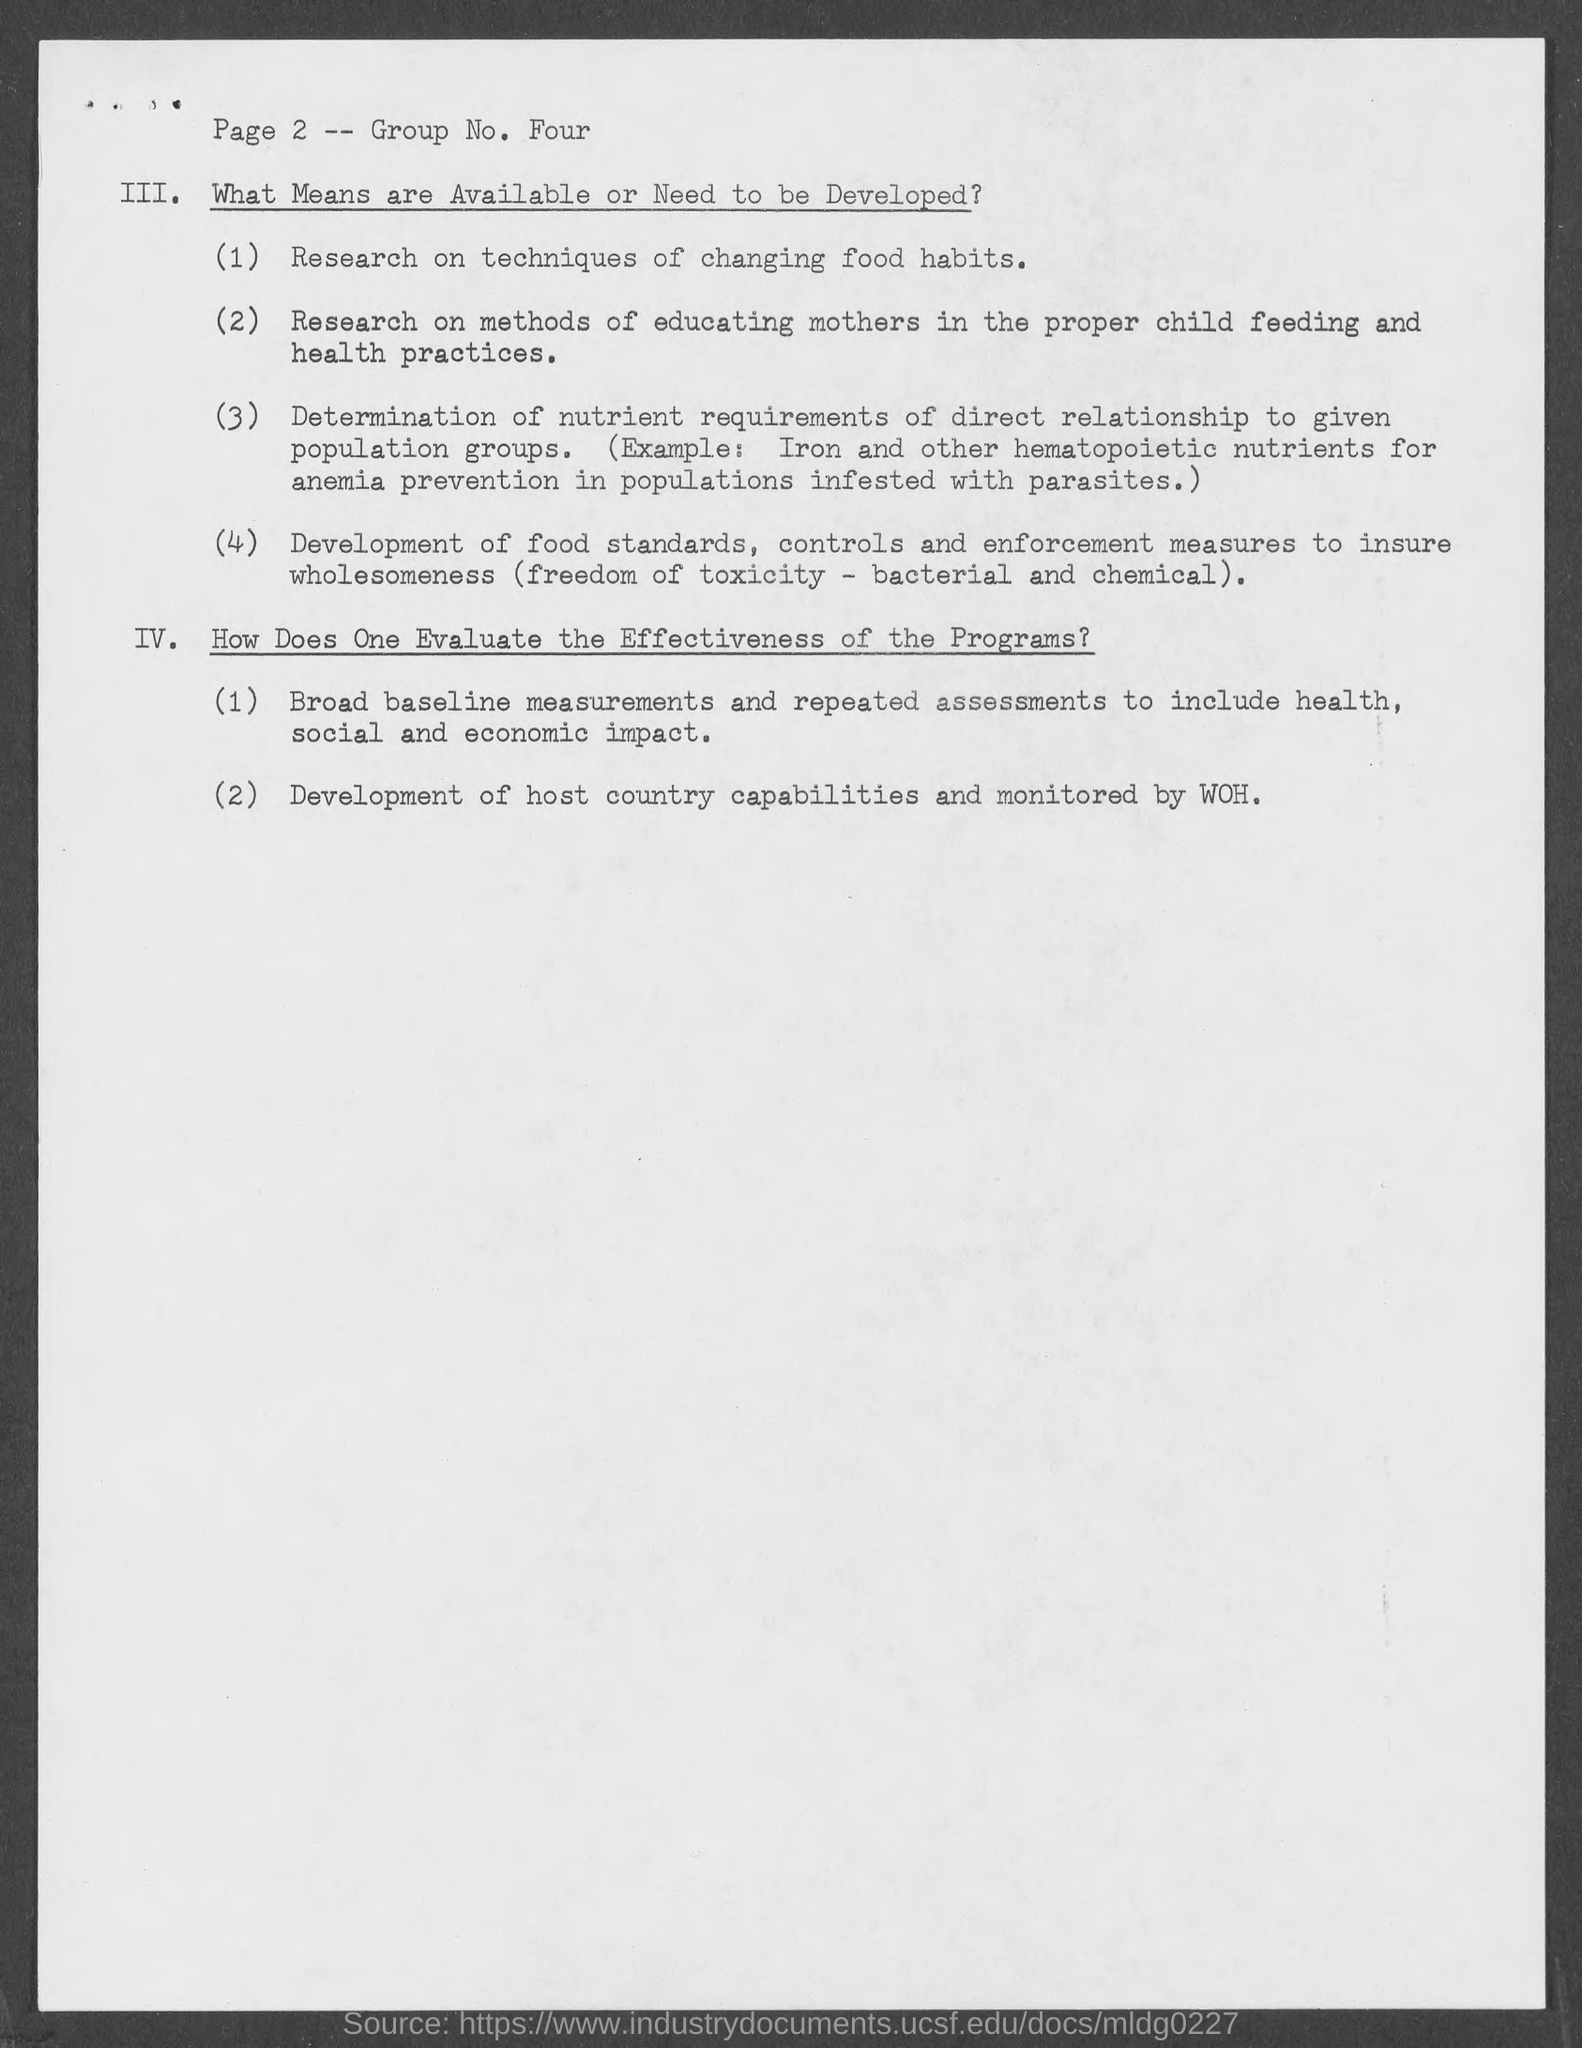Indicate a few pertinent items in this graphic. The Group Number mentioned in the document is four. The development of host country capabilities and their subsequent monitoring are of utmost importance in ensuring the success of an outsourcing partnership. The page number mentioned in the document is 2. 